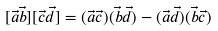Convert formula to latex. <formula><loc_0><loc_0><loc_500><loc_500>[ \vec { a } \vec { b } ] [ \vec { c } \vec { d } ] = ( \vec { a } \vec { c } ) ( \vec { b } \vec { d } ) - ( \vec { a } \vec { d } ) ( \vec { b } \vec { c } )</formula> 